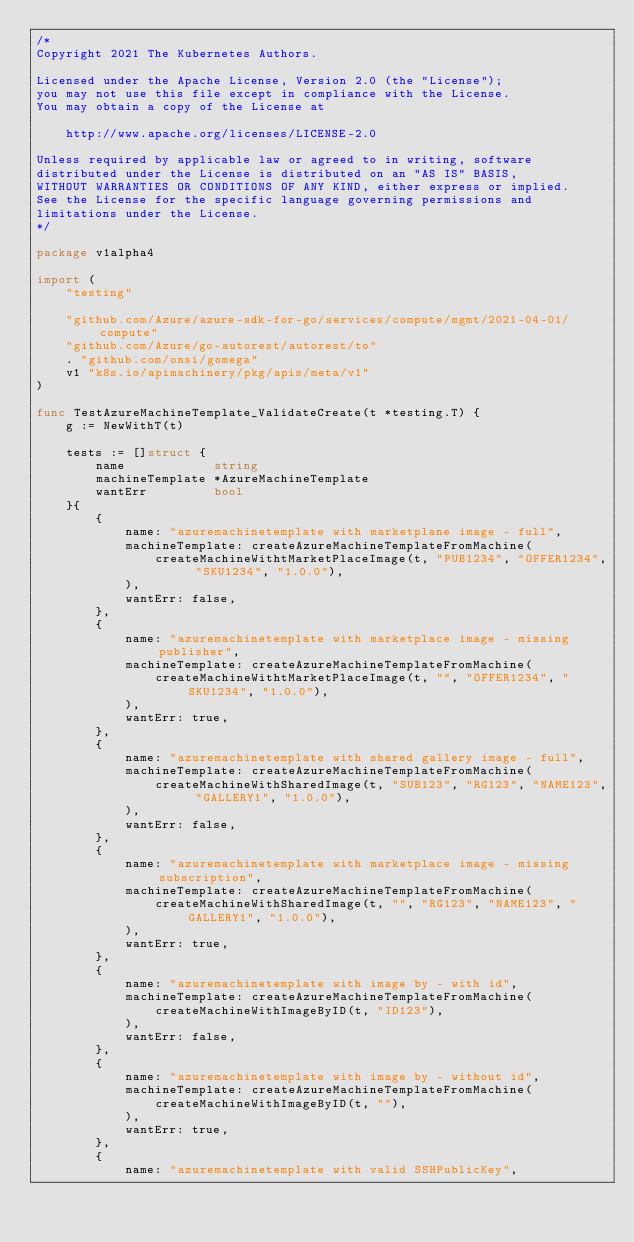Convert code to text. <code><loc_0><loc_0><loc_500><loc_500><_Go_>/*
Copyright 2021 The Kubernetes Authors.

Licensed under the Apache License, Version 2.0 (the "License");
you may not use this file except in compliance with the License.
You may obtain a copy of the License at

    http://www.apache.org/licenses/LICENSE-2.0

Unless required by applicable law or agreed to in writing, software
distributed under the License is distributed on an "AS IS" BASIS,
WITHOUT WARRANTIES OR CONDITIONS OF ANY KIND, either express or implied.
See the License for the specific language governing permissions and
limitations under the License.
*/

package v1alpha4

import (
	"testing"

	"github.com/Azure/azure-sdk-for-go/services/compute/mgmt/2021-04-01/compute"
	"github.com/Azure/go-autorest/autorest/to"
	. "github.com/onsi/gomega"
	v1 "k8s.io/apimachinery/pkg/apis/meta/v1"
)

func TestAzureMachineTemplate_ValidateCreate(t *testing.T) {
	g := NewWithT(t)

	tests := []struct {
		name            string
		machineTemplate *AzureMachineTemplate
		wantErr         bool
	}{
		{
			name: "azuremachinetemplate with marketplane image - full",
			machineTemplate: createAzureMachineTemplateFromMachine(
				createMachineWithtMarketPlaceImage(t, "PUB1234", "OFFER1234", "SKU1234", "1.0.0"),
			),
			wantErr: false,
		},
		{
			name: "azuremachinetemplate with marketplace image - missing publisher",
			machineTemplate: createAzureMachineTemplateFromMachine(
				createMachineWithtMarketPlaceImage(t, "", "OFFER1234", "SKU1234", "1.0.0"),
			),
			wantErr: true,
		},
		{
			name: "azuremachinetemplate with shared gallery image - full",
			machineTemplate: createAzureMachineTemplateFromMachine(
				createMachineWithSharedImage(t, "SUB123", "RG123", "NAME123", "GALLERY1", "1.0.0"),
			),
			wantErr: false,
		},
		{
			name: "azuremachinetemplate with marketplace image - missing subscription",
			machineTemplate: createAzureMachineTemplateFromMachine(
				createMachineWithSharedImage(t, "", "RG123", "NAME123", "GALLERY1", "1.0.0"),
			),
			wantErr: true,
		},
		{
			name: "azuremachinetemplate with image by - with id",
			machineTemplate: createAzureMachineTemplateFromMachine(
				createMachineWithImageByID(t, "ID123"),
			),
			wantErr: false,
		},
		{
			name: "azuremachinetemplate with image by - without id",
			machineTemplate: createAzureMachineTemplateFromMachine(
				createMachineWithImageByID(t, ""),
			),
			wantErr: true,
		},
		{
			name: "azuremachinetemplate with valid SSHPublicKey",</code> 